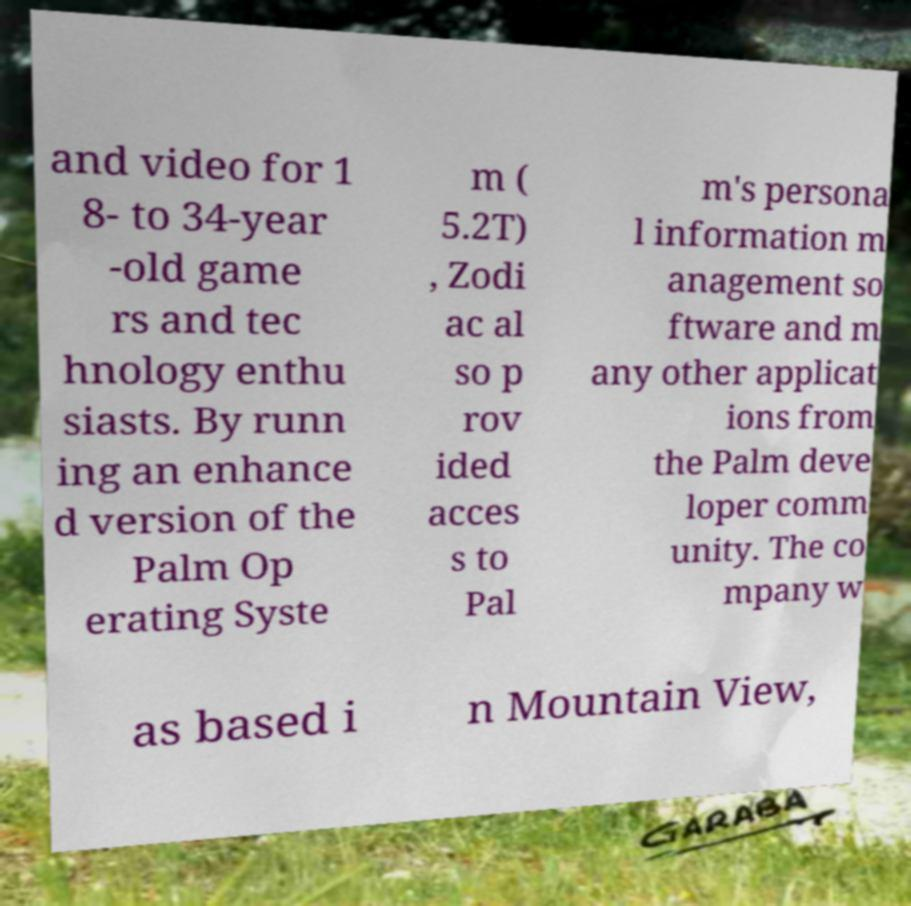Could you extract and type out the text from this image? and video for 1 8- to 34-year -old game rs and tec hnology enthu siasts. By runn ing an enhance d version of the Palm Op erating Syste m ( 5.2T) , Zodi ac al so p rov ided acces s to Pal m's persona l information m anagement so ftware and m any other applicat ions from the Palm deve loper comm unity. The co mpany w as based i n Mountain View, 